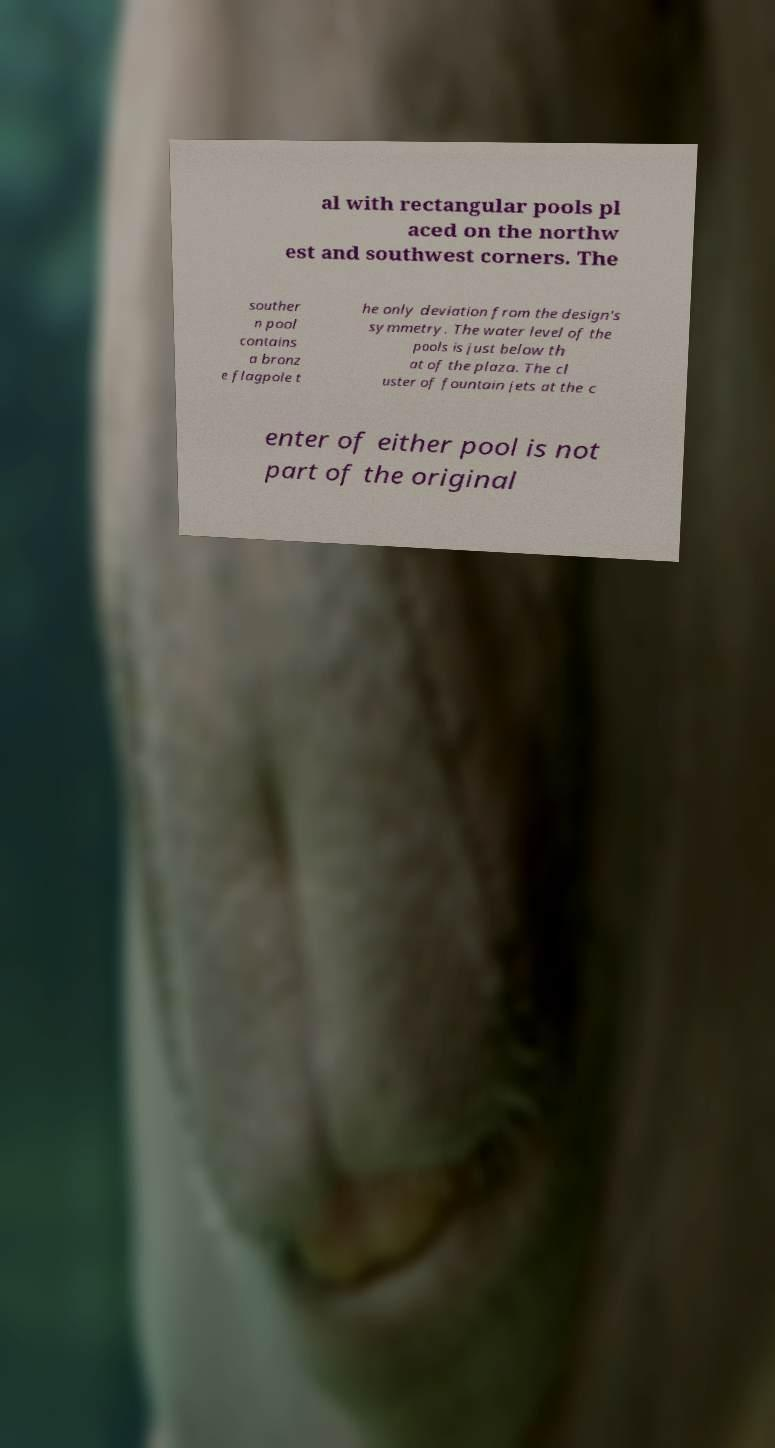There's text embedded in this image that I need extracted. Can you transcribe it verbatim? al with rectangular pools pl aced on the northw est and southwest corners. The souther n pool contains a bronz e flagpole t he only deviation from the design's symmetry. The water level of the pools is just below th at of the plaza. The cl uster of fountain jets at the c enter of either pool is not part of the original 